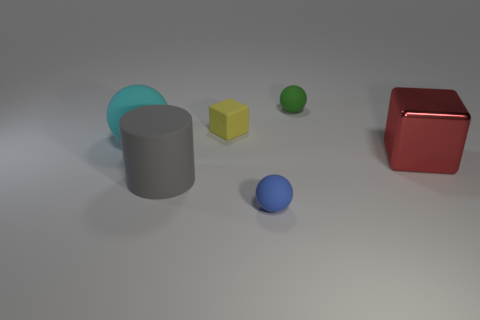Add 2 big green metal balls. How many objects exist? 8 Subtract all cubes. How many objects are left? 4 Subtract all brown cylinders. Subtract all metallic blocks. How many objects are left? 5 Add 4 tiny rubber things. How many tiny rubber things are left? 7 Add 6 tiny cyan matte spheres. How many tiny cyan matte spheres exist? 6 Subtract 0 gray cubes. How many objects are left? 6 